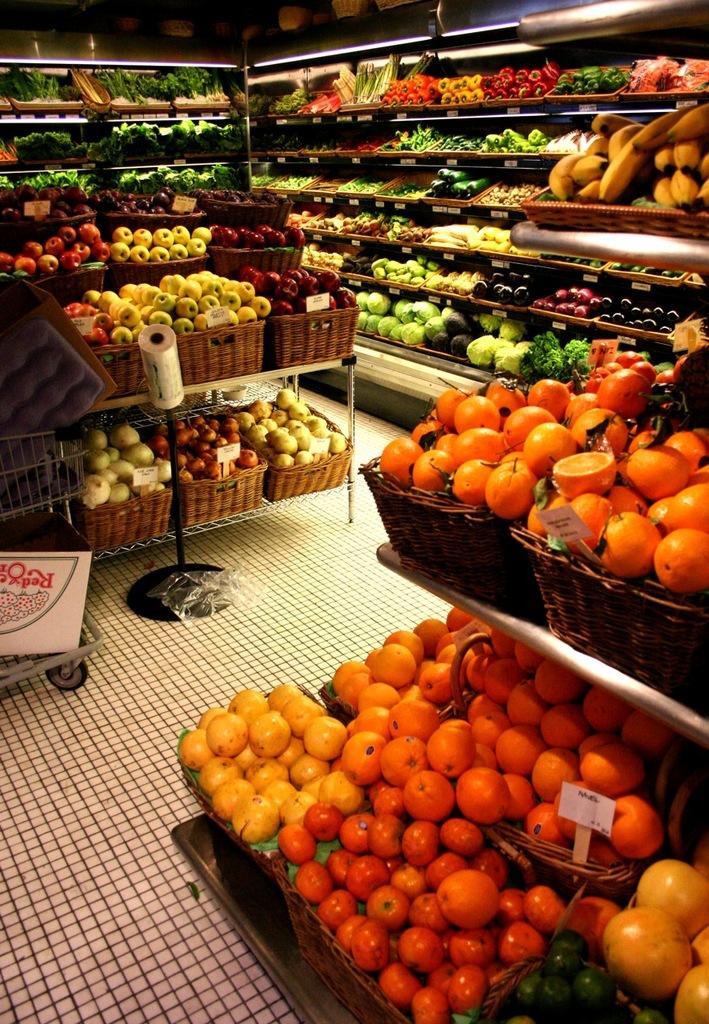Can you describe this image briefly? In the picture we can see a supermarket with fruits and vegetables filled with the racks and on the tables with baskets. 